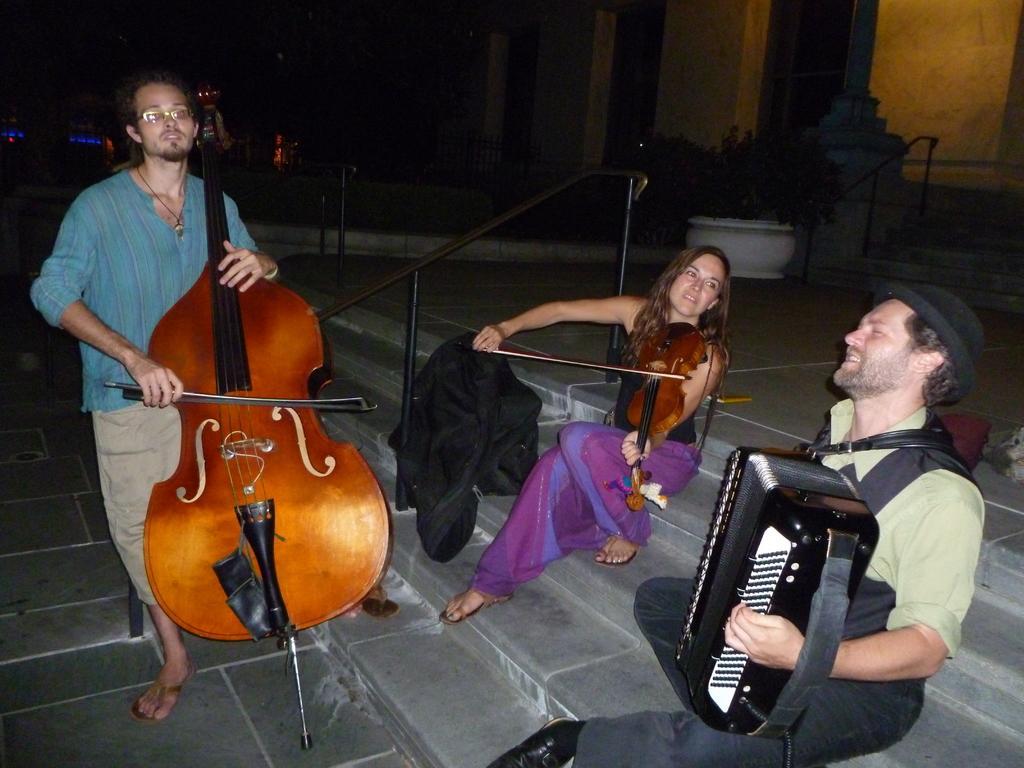Please provide a concise description of this image. In this picture there are two people playing violin and a guy is playing a piano. These are sitting on the steps and the guy is standing. In the background there are few trees and pillars of the building. 